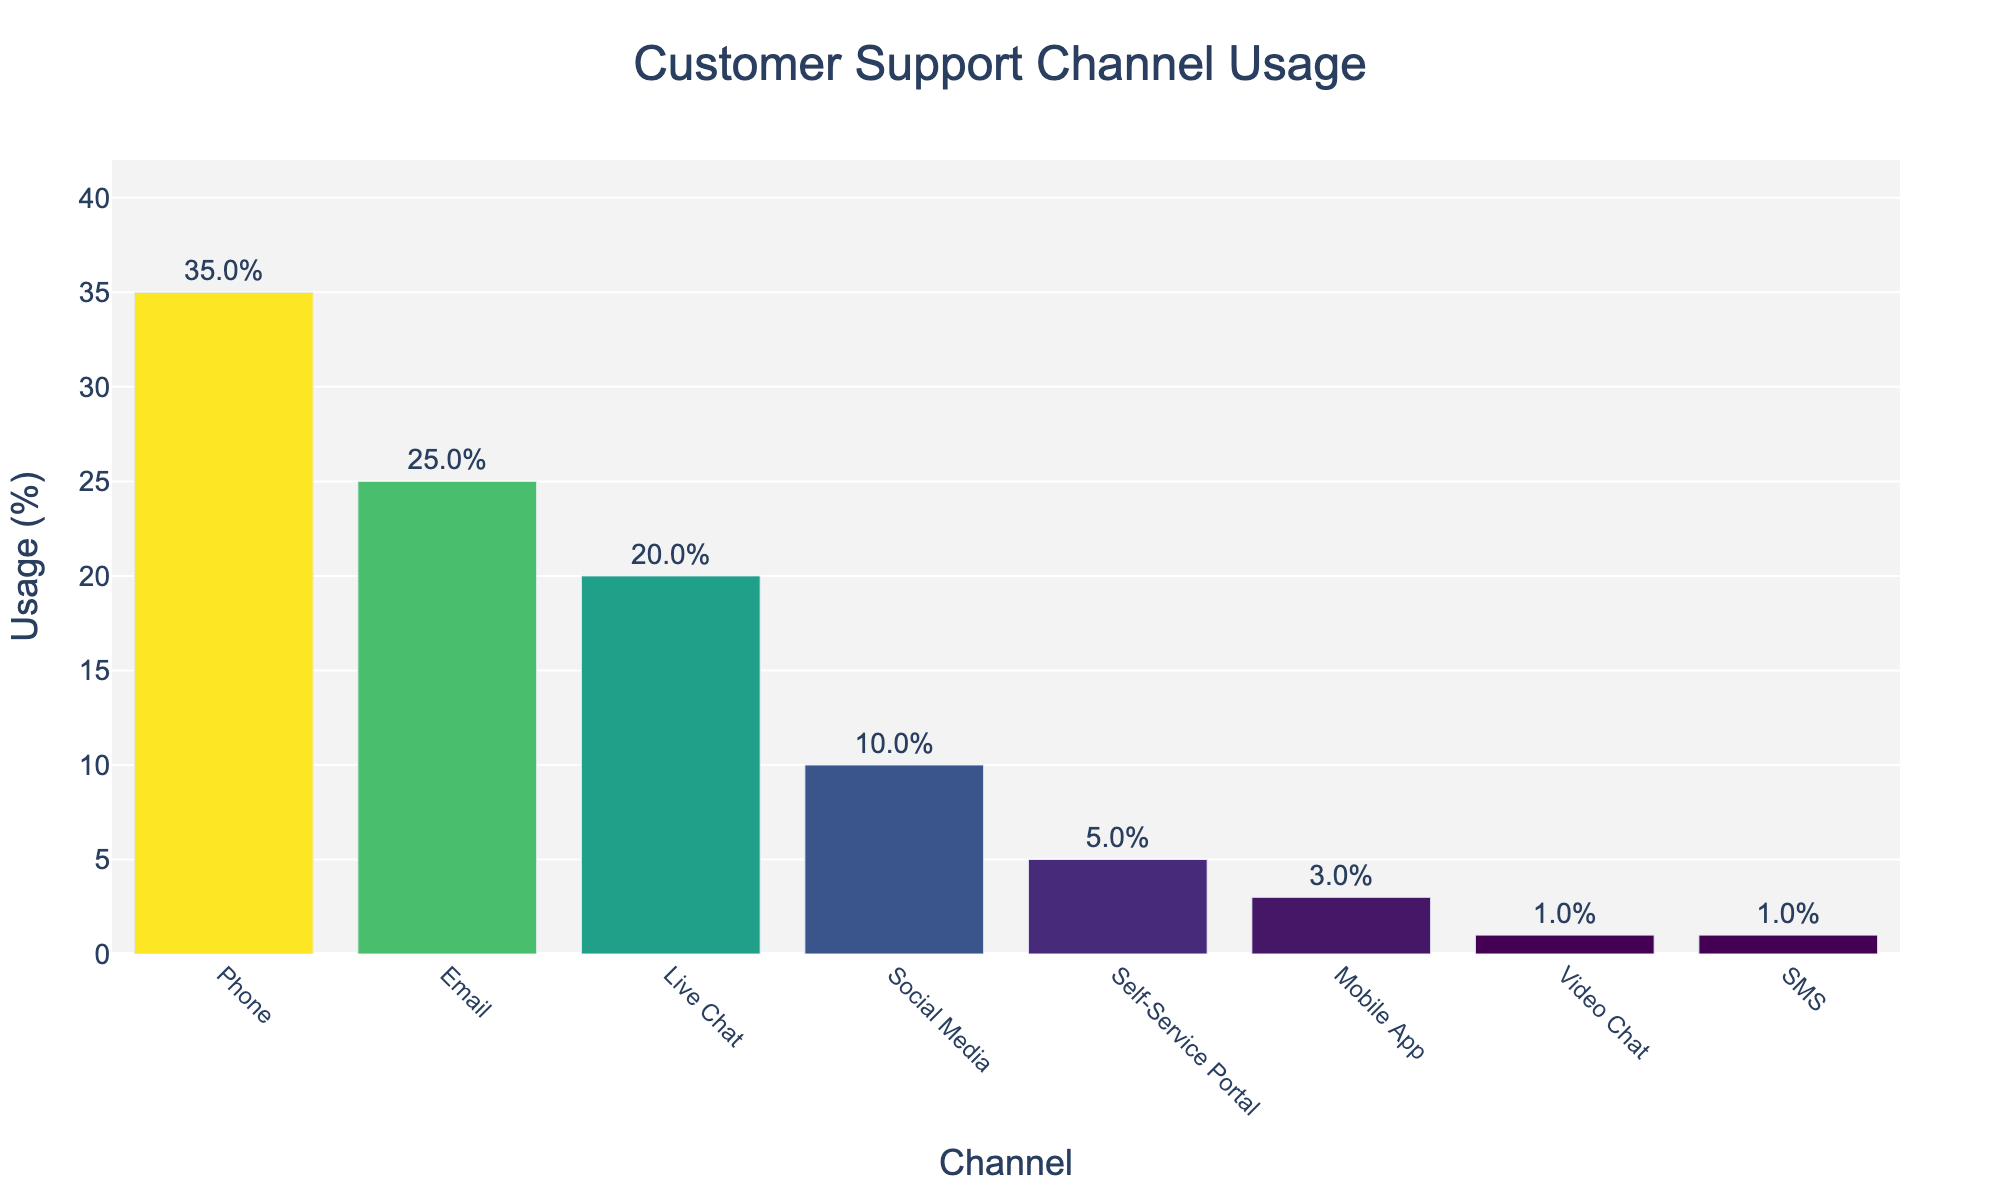What's the most used customer support channel? The bar for "Phone" is the highest, indicating it has the largest percentage.
Answer: Phone Which support channel has the same usage percentage as SMS? Both "SMS" and "Video Chat" have the same height, representing 1%.
Answer: Video Chat By how much does the usage of Live Chat exceed the usage of Social Media? The percentage for "Live Chat" is 20%, and for "Social Media" it is 10%. The difference is 20% - 10% = 10%.
Answer: 10% What is the cumulative percentage usage of Email, Live Chat, and Social Media channels? The percentages are 25% for Email, 20% for Live Chat, and 10% for Social Media. Summing these up: 25% + 20% + 10% = 55%.
Answer: 55% Which support channel has the least usage? The bar for "Video Chat" is the shortest, signifying the smallest percentage, which is 1%.
Answer: Video Chat What is the total percentage usage of the Self-Service Portal and Mobile App? The percentages are 5% for Self-Service Portal and 3% for Mobile App. Adding these: 5% + 3% = 8%.
Answer: 8% Is the percentage usage of Email greater than that of Social Media? The bar for "Email" shows 25%, which is greater than the 10% for "Social Media".
Answer: Yes What proportion of channels have a usage percentage of 10% or lesser? The channels "Social Media" (10%), "Self-Service Portal" (5%), "Mobile App" (3%), "Video Chat" (1%), and "SMS" (1%) all have usage percentages of 10% or lesser. There are 8 channels total, so 5/8 ≈ 62.5%.
Answer: Approximately 62.5% How much more usage does the Phone channel have compared to the Email channel? The percentage for "Phone" is 35%, and for "Email" it is 25%. The difference is 35% - 25% = 10%.
Answer: 10% What is the average percentage usage across all channels? Summing all percentages: 35% + 25% + 20% + 10% + 5% + 3% + 1% + 1% = 100%. There are 8 channels, so the average is 100% / 8 = 12.5%.
Answer: 12.5% 